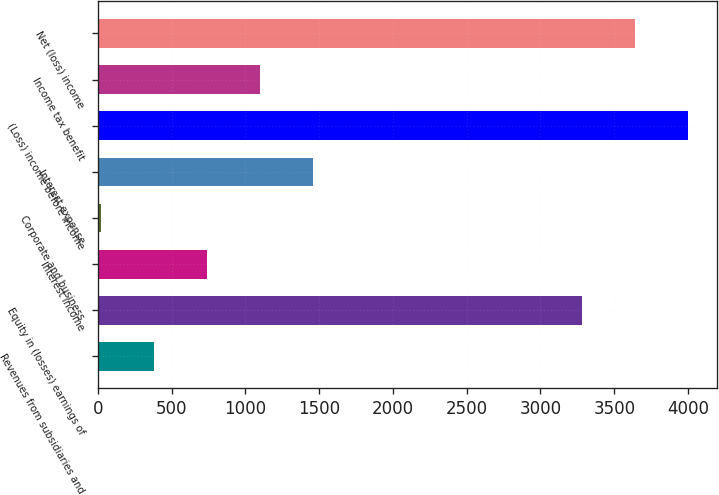Convert chart to OTSL. <chart><loc_0><loc_0><loc_500><loc_500><bar_chart><fcel>Revenues from subsidiaries and<fcel>Equity in (losses) earnings of<fcel>Interest income<fcel>Corporate and business<fcel>Interest expense<fcel>(Loss) income before income<fcel>Income tax benefit<fcel>Net (loss) income<nl><fcel>382.3<fcel>3280<fcel>740.6<fcel>24<fcel>1457.2<fcel>3996.6<fcel>1098.9<fcel>3638.3<nl></chart> 